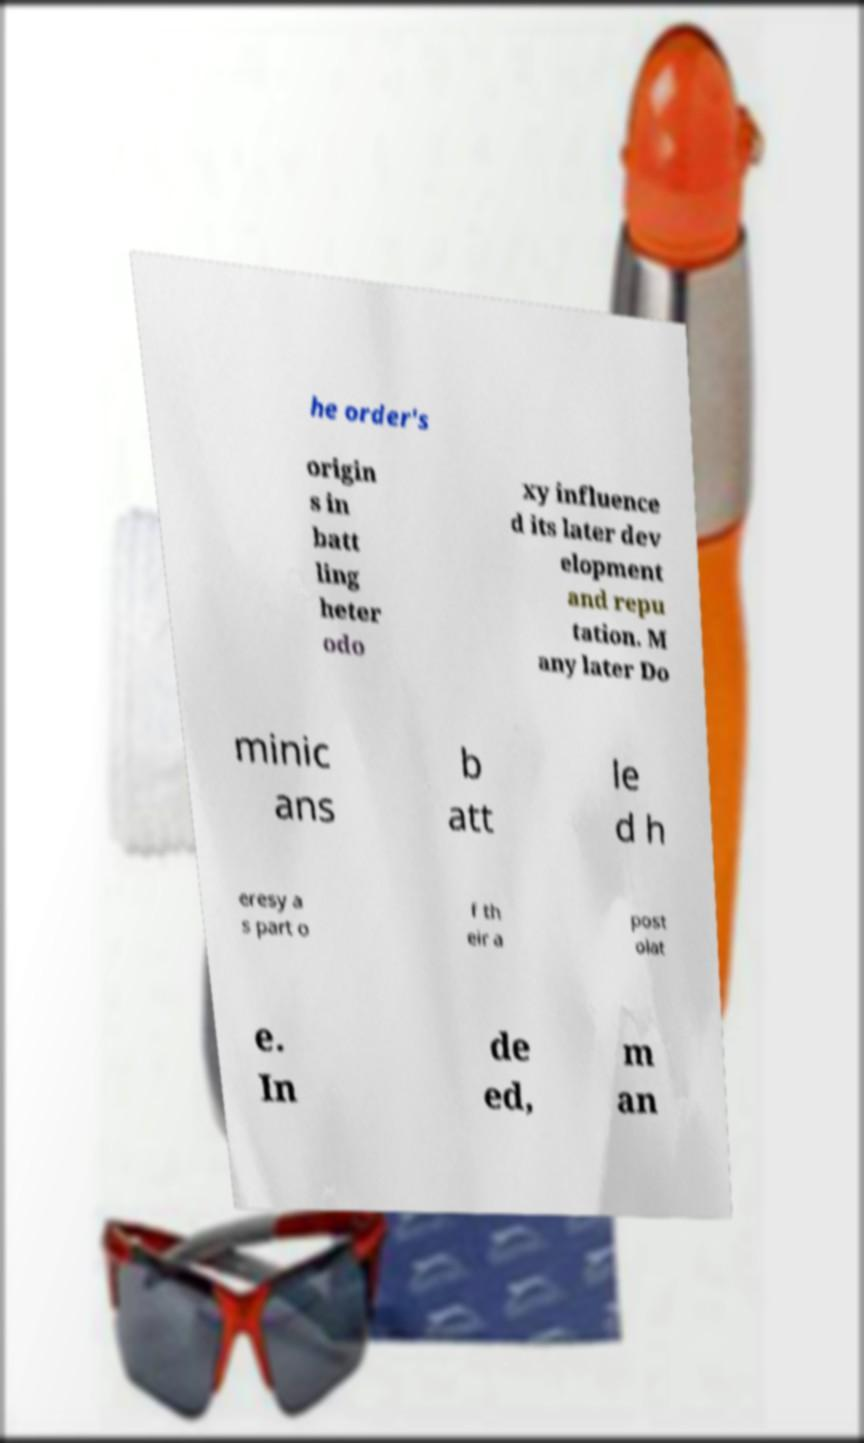Can you read and provide the text displayed in the image?This photo seems to have some interesting text. Can you extract and type it out for me? he order's origin s in batt ling heter odo xy influence d its later dev elopment and repu tation. M any later Do minic ans b att le d h eresy a s part o f th eir a post olat e. In de ed, m an 